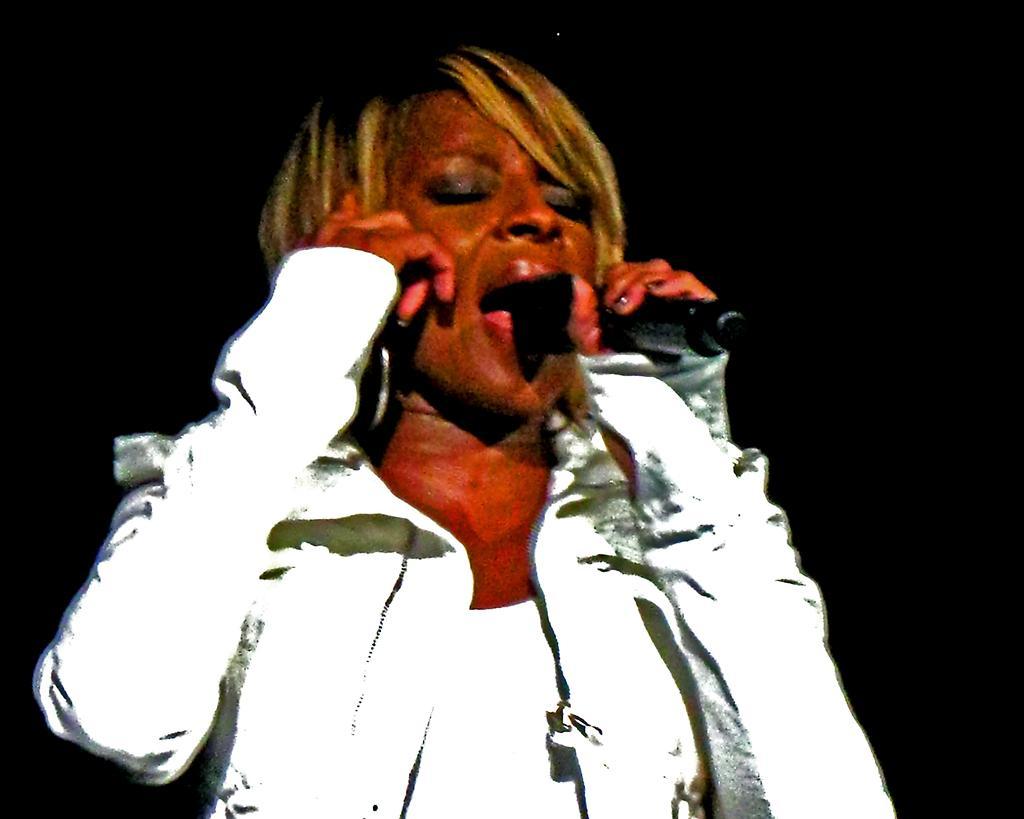How would you summarize this image in a sentence or two? Here, we can see a person standing and holding a microphone, there is a dark background. 